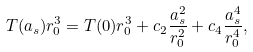Convert formula to latex. <formula><loc_0><loc_0><loc_500><loc_500>T ( a _ { s } ) r _ { 0 } ^ { 3 } = T ( 0 ) r _ { 0 } ^ { 3 } + c _ { 2 } \frac { a _ { s } ^ { 2 } } { r _ { 0 } ^ { 2 } } + c _ { 4 } \frac { a _ { s } ^ { 4 } } { r _ { 0 } ^ { 4 } } ,</formula> 